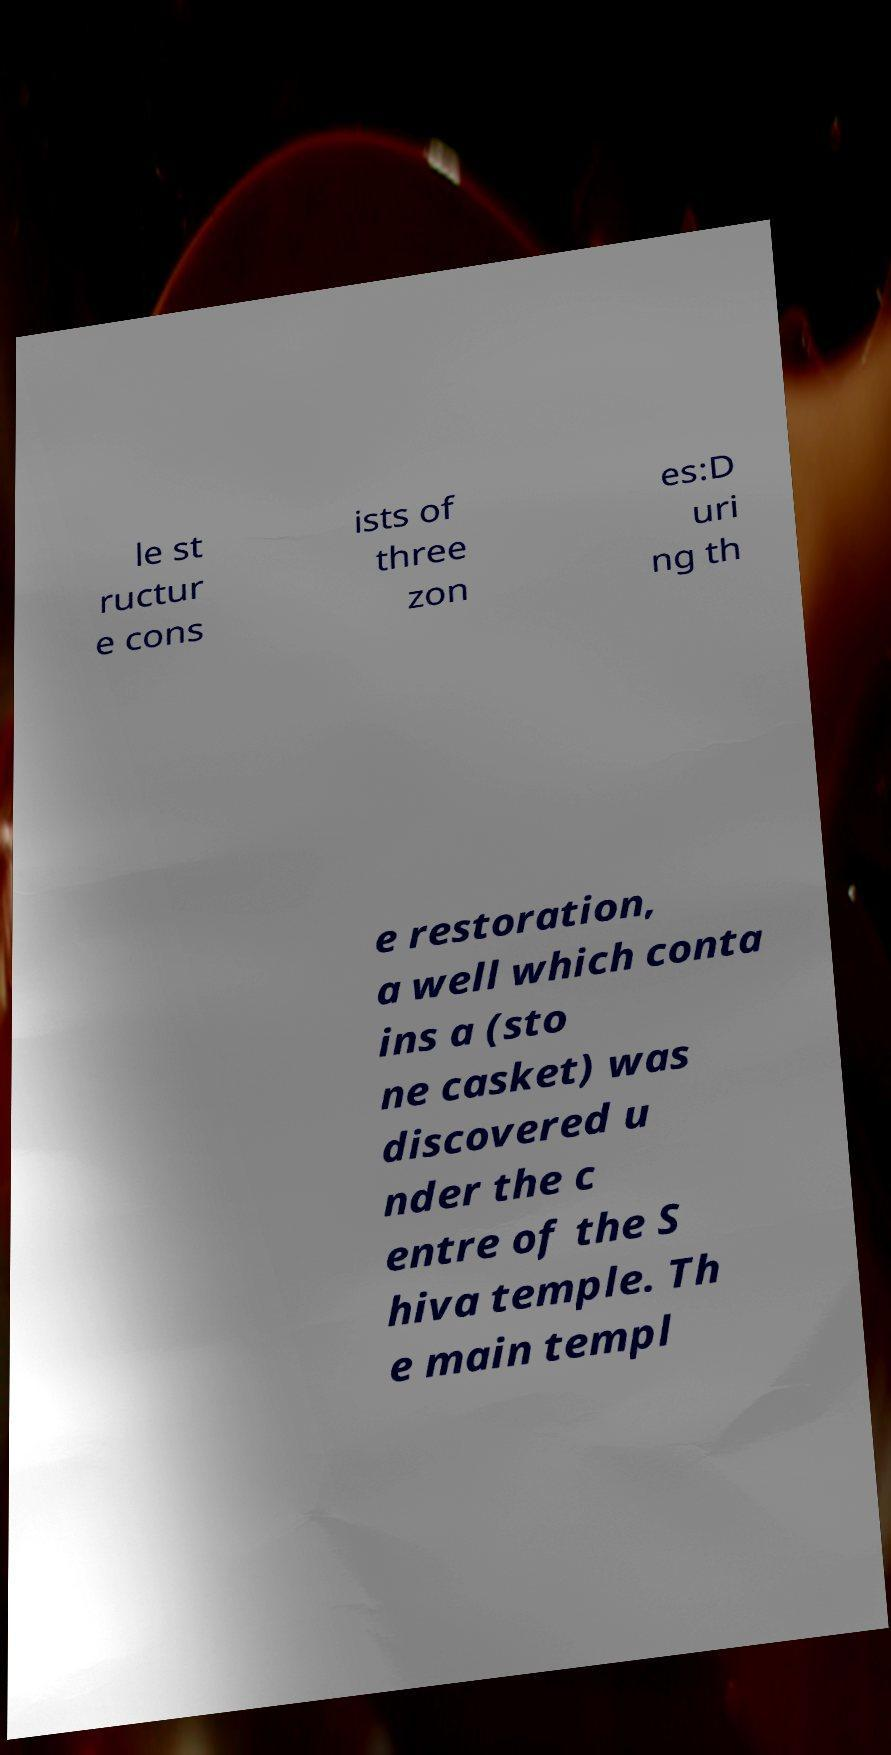For documentation purposes, I need the text within this image transcribed. Could you provide that? le st ructur e cons ists of three zon es:D uri ng th e restoration, a well which conta ins a (sto ne casket) was discovered u nder the c entre of the S hiva temple. Th e main templ 